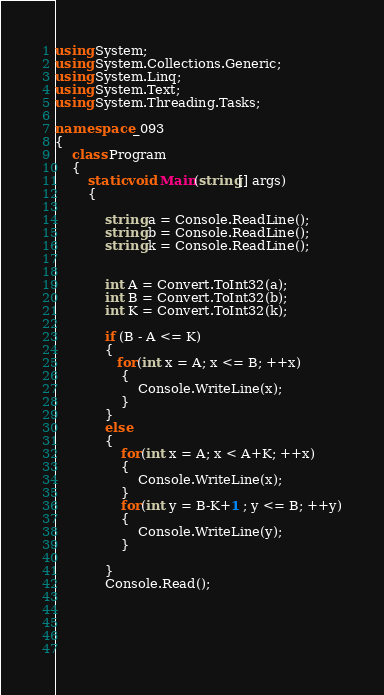Convert code to text. <code><loc_0><loc_0><loc_500><loc_500><_C#_>using System;
using System.Collections.Generic;
using System.Linq;
using System.Text;
using System.Threading.Tasks;

namespace _093
{
    class Program
    {
        static void Main(string[] args)
        {

            string a = Console.ReadLine();
            string b = Console.ReadLine();
            string k = Console.ReadLine();


            int A = Convert.ToInt32(a); 
            int B = Convert.ToInt32(b);
            int K = Convert.ToInt32(k);

            if (B - A <= K)
            {
               for(int x = A; x <= B; ++x)
                {
                    Console.WriteLine(x);
                }
            }
            else
            {
                for(int x = A; x < A+K; ++x)
                {
                    Console.WriteLine(x);
                }
                for(int y = B-K+1 ; y <= B; ++y)
                {
                    Console.WriteLine(y);
                }

            }
            Console.Read();




            </code> 